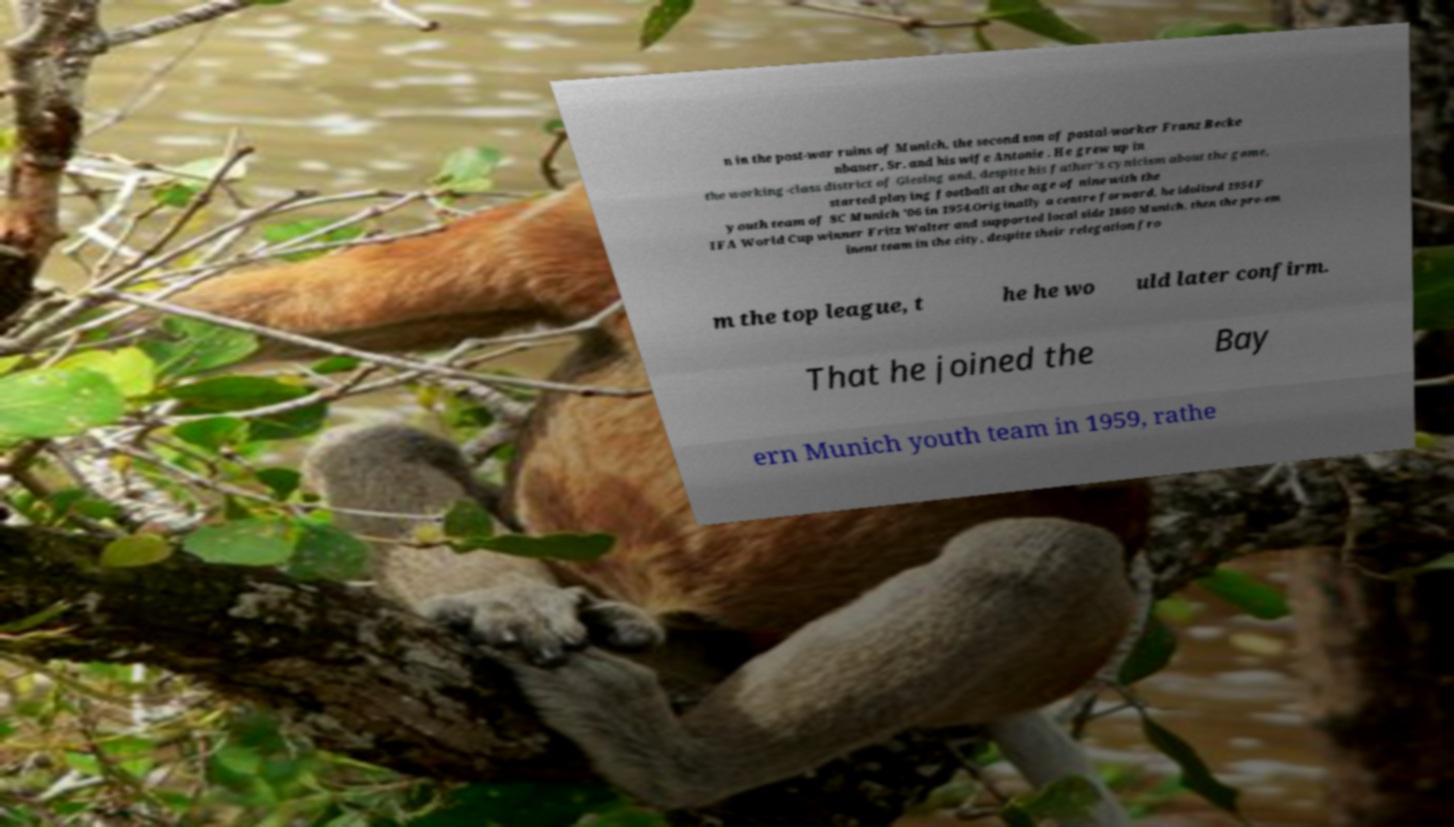Can you accurately transcribe the text from the provided image for me? n in the post-war ruins of Munich, the second son of postal-worker Franz Becke nbauer, Sr. and his wife Antonie . He grew up in the working-class district of Giesing and, despite his father's cynicism about the game, started playing football at the age of nine with the youth team of SC Munich '06 in 1954.Originally a centre forward, he idolised 1954 F IFA World Cup winner Fritz Walter and supported local side 1860 Munich, then the pre-em inent team in the city, despite their relegation fro m the top league, t he he wo uld later confirm. That he joined the Bay ern Munich youth team in 1959, rathe 